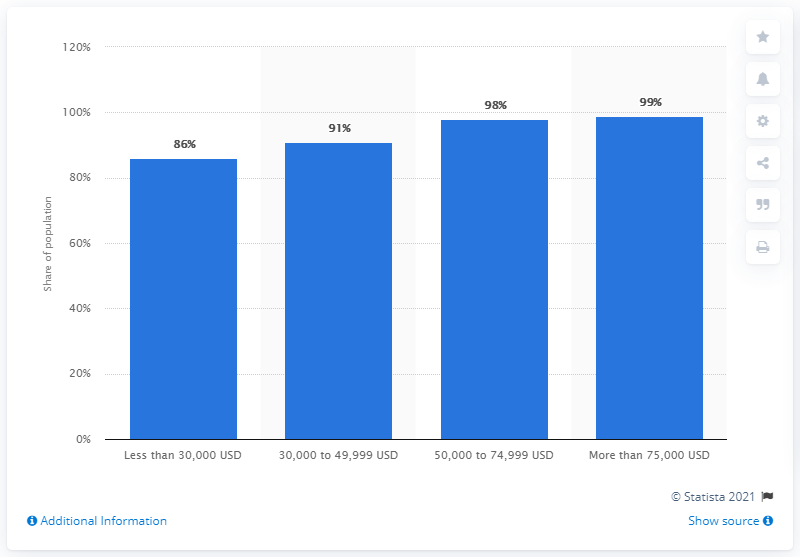Indicate a few pertinent items in this graphic. In 2019, approximately 86% of individuals with an annual household income of less than $30,000 in the United States were internet users. 